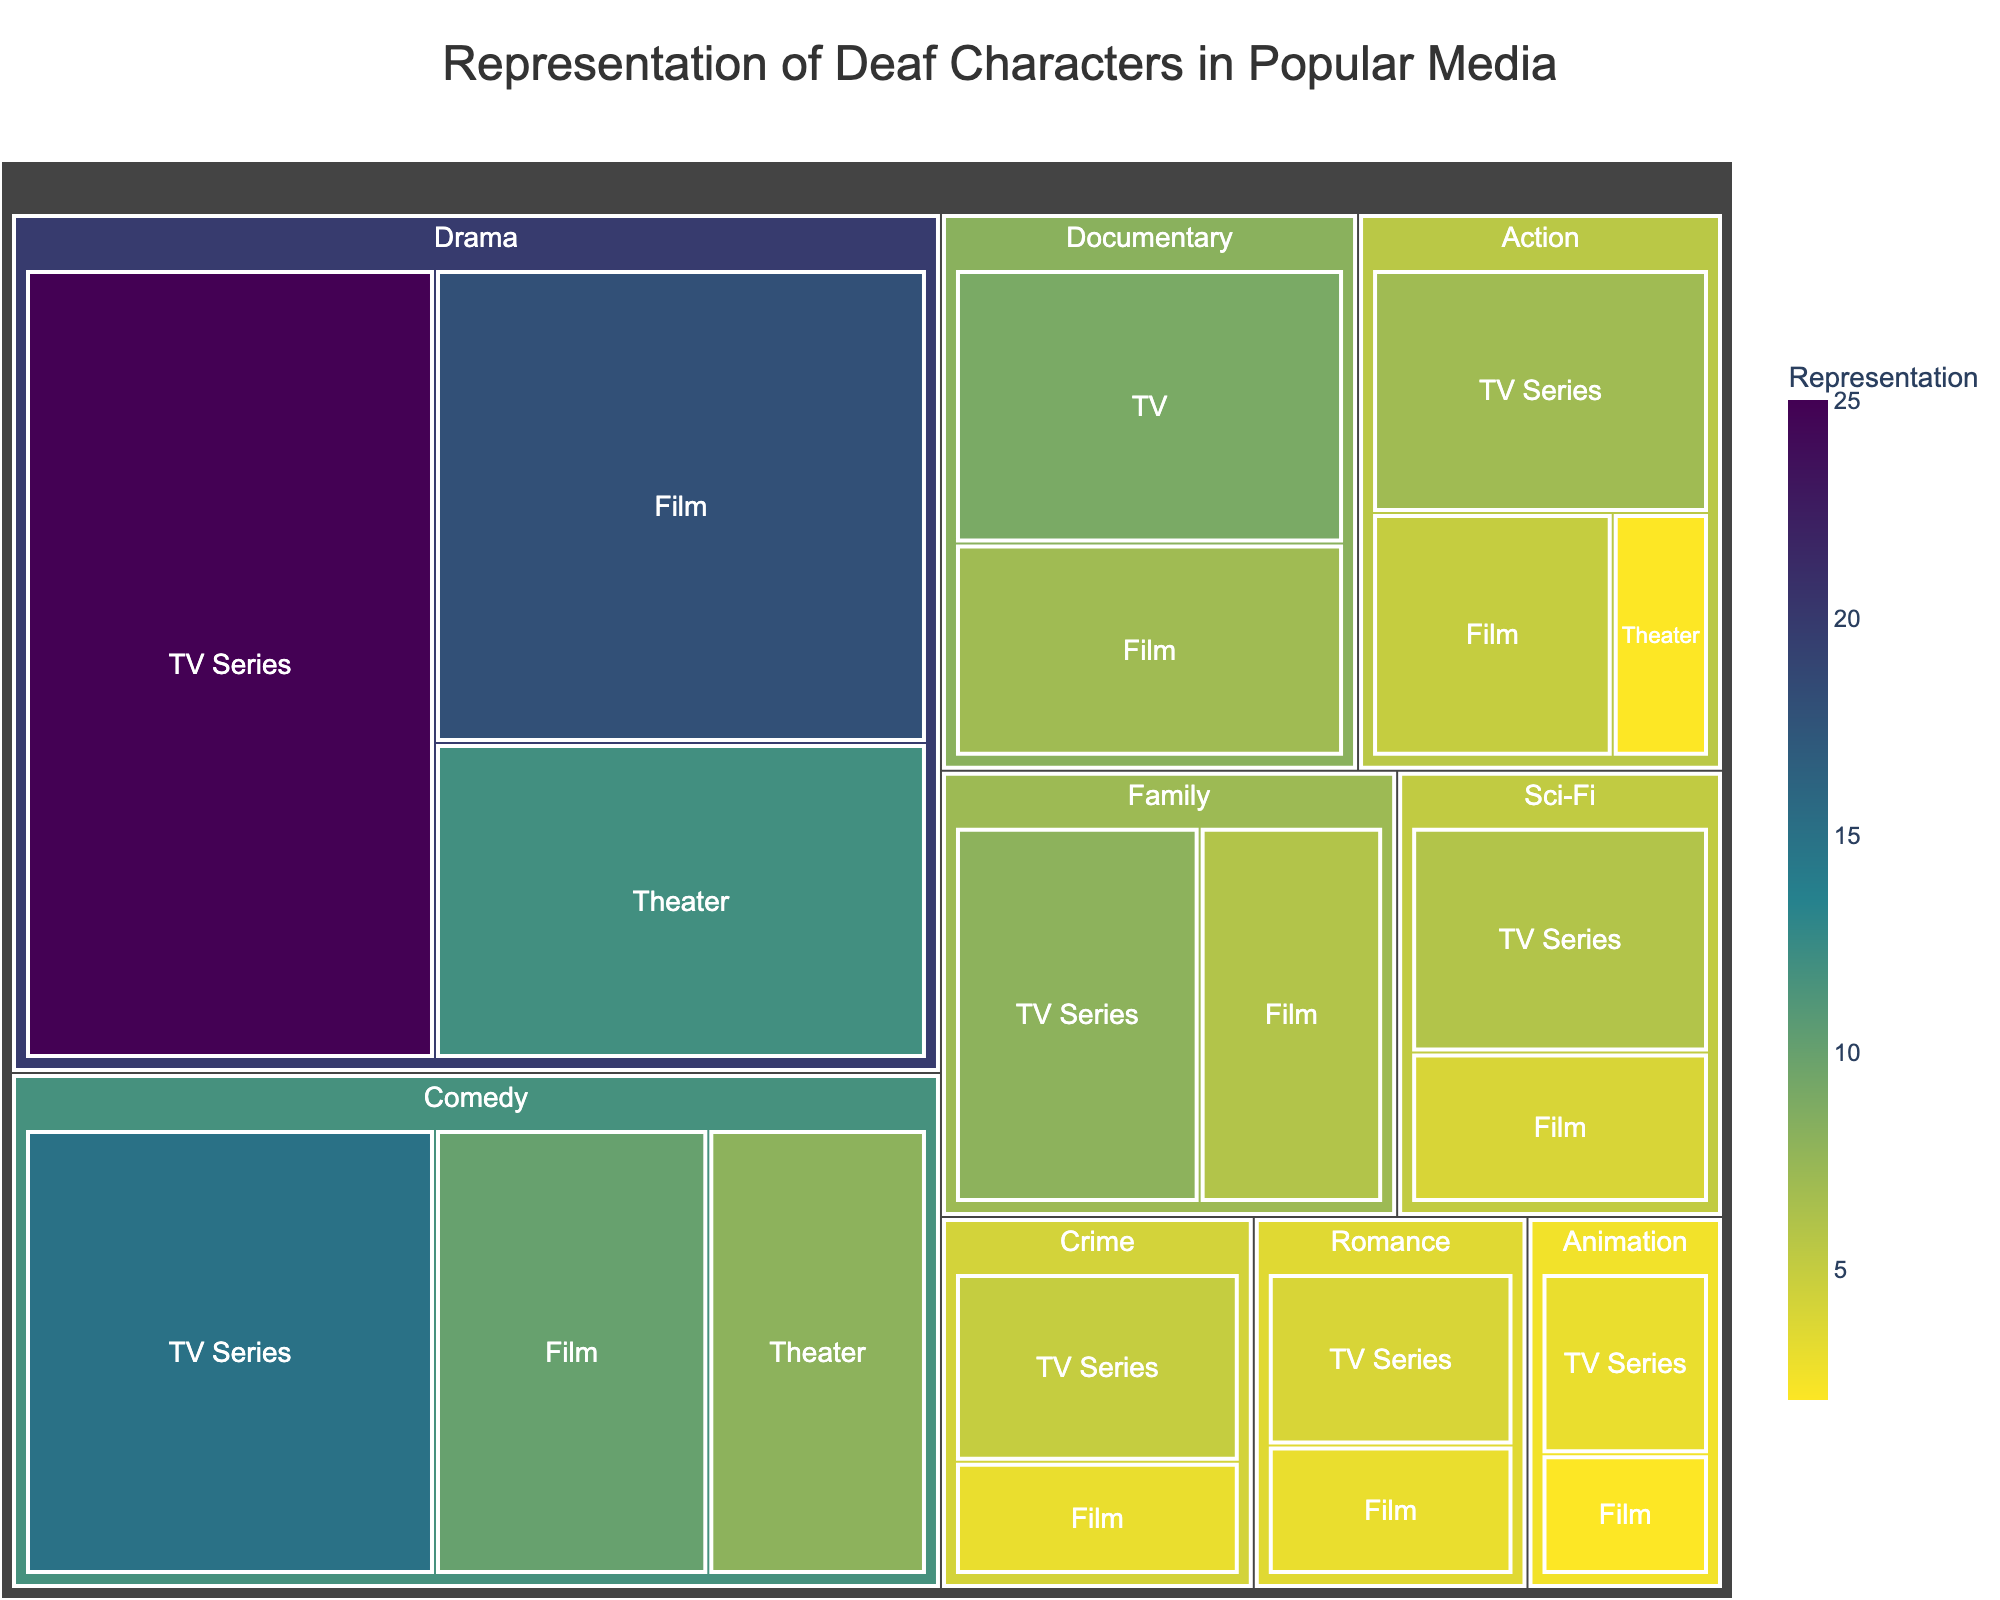What's the title of the treemap? The title is placed at the top center of the plot and describes the content of the treemap.
Answer: Representation of Deaf Characters in Popular Media Which genre has the highest representation of deaf characters? Look at the treemap and identify the largest section by area. The largest section represents Drama.
Answer: Drama What is the total representation of deaf characters in Drama across all categories? Sum the representations for Drama in TV Series, Film, and Theater: 25 + 18 + 12 = 55.
Answer: 55 How does the representation in Comedy TV Series compare to Comedy Film? Compare the values for Comedy in TV Series and Film; TV Series has 15, and Film has 10.
Answer: Comedy TV Series has more What genre has the smallest total representation of deaf characters and what is its value? Compare the sum of the representations across all categories for each genre. Animation has the smallest: 3 (TV Series) + 2 (Film) = 5.
Answer: Animation, 5 Which category within the Sci-Fi genre has the highest representation of deaf characters? Look at the Sci-Fi genre section and compare the representation of deaf characters in TV Series and Film. TV Series has 6, Film has 4.
Answer: TV Series How does the representation in Family Film compare to Family TV Series? Compare the values for Family in TV Series and Film; TV Series has 8, Film has 6.
Answer: Family TV Series has more What is the average representation of deaf characters in the Theater category across all genres? Sum the representation of Theater across genres: 12 (Drama) + 8 (Comedy) + 2 (Action), then divide by 3 (number of genres in Theater). (12 + 8 + 2) / 3 = 22 / 3 = 7.33.
Answer: 7.33 Which genre and category combination has exactly 7 representations of deaf characters? Look at the treemap for any section labeled with 7 representations. Action Film has exactly 7.
Answer: Action, TV Series Is the representation in Documentary TV higher or lower than Documentary Film? Compare the values for Documentary in TV and Film; TV has 9, Film has 7.
Answer: Documentary TV is higher 